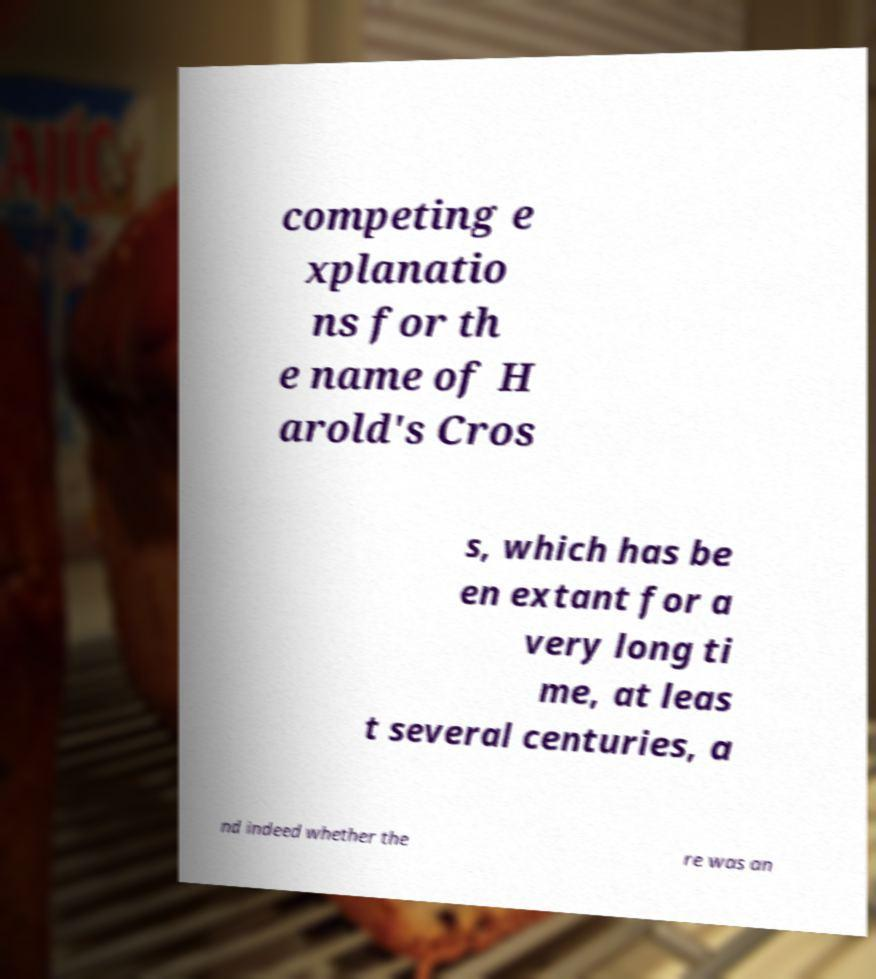Could you assist in decoding the text presented in this image and type it out clearly? competing e xplanatio ns for th e name of H arold's Cros s, which has be en extant for a very long ti me, at leas t several centuries, a nd indeed whether the re was an 